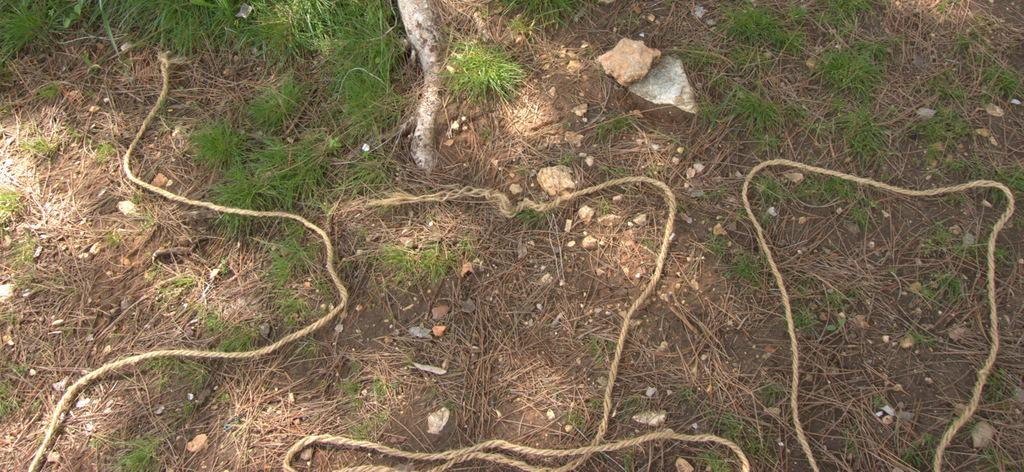What objects can be seen on the ground in the image? There are ropes and stones on the ground in the image. What type of vegetation is present in the image? There is grass in the image. How many snails can be seen crawling on the grass in the image? There are no snails visible in the image; it only shows ropes, stones, and grass. 